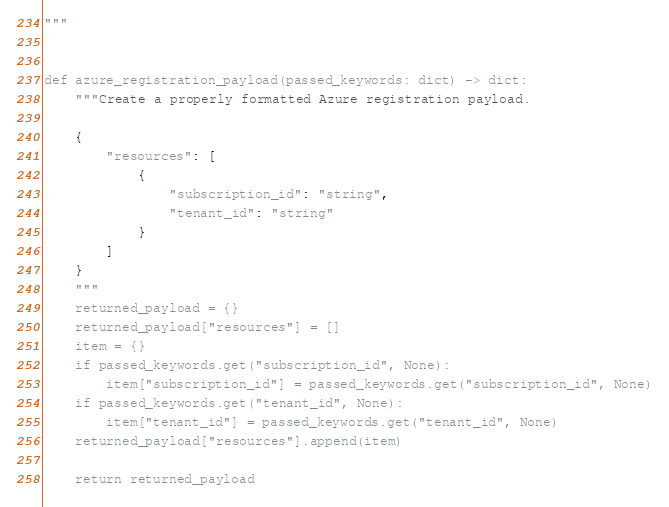<code> <loc_0><loc_0><loc_500><loc_500><_Python_>"""


def azure_registration_payload(passed_keywords: dict) -> dict:
    """Create a properly formatted Azure registration payload.

    {
        "resources": [
            {
                "subscription_id": "string",
                "tenant_id": "string"
            }
        ]
    }
    """
    returned_payload = {}
    returned_payload["resources"] = []
    item = {}
    if passed_keywords.get("subscription_id", None):
        item["subscription_id"] = passed_keywords.get("subscription_id", None)
    if passed_keywords.get("tenant_id", None):
        item["tenant_id"] = passed_keywords.get("tenant_id", None)
    returned_payload["resources"].append(item)

    return returned_payload
</code> 